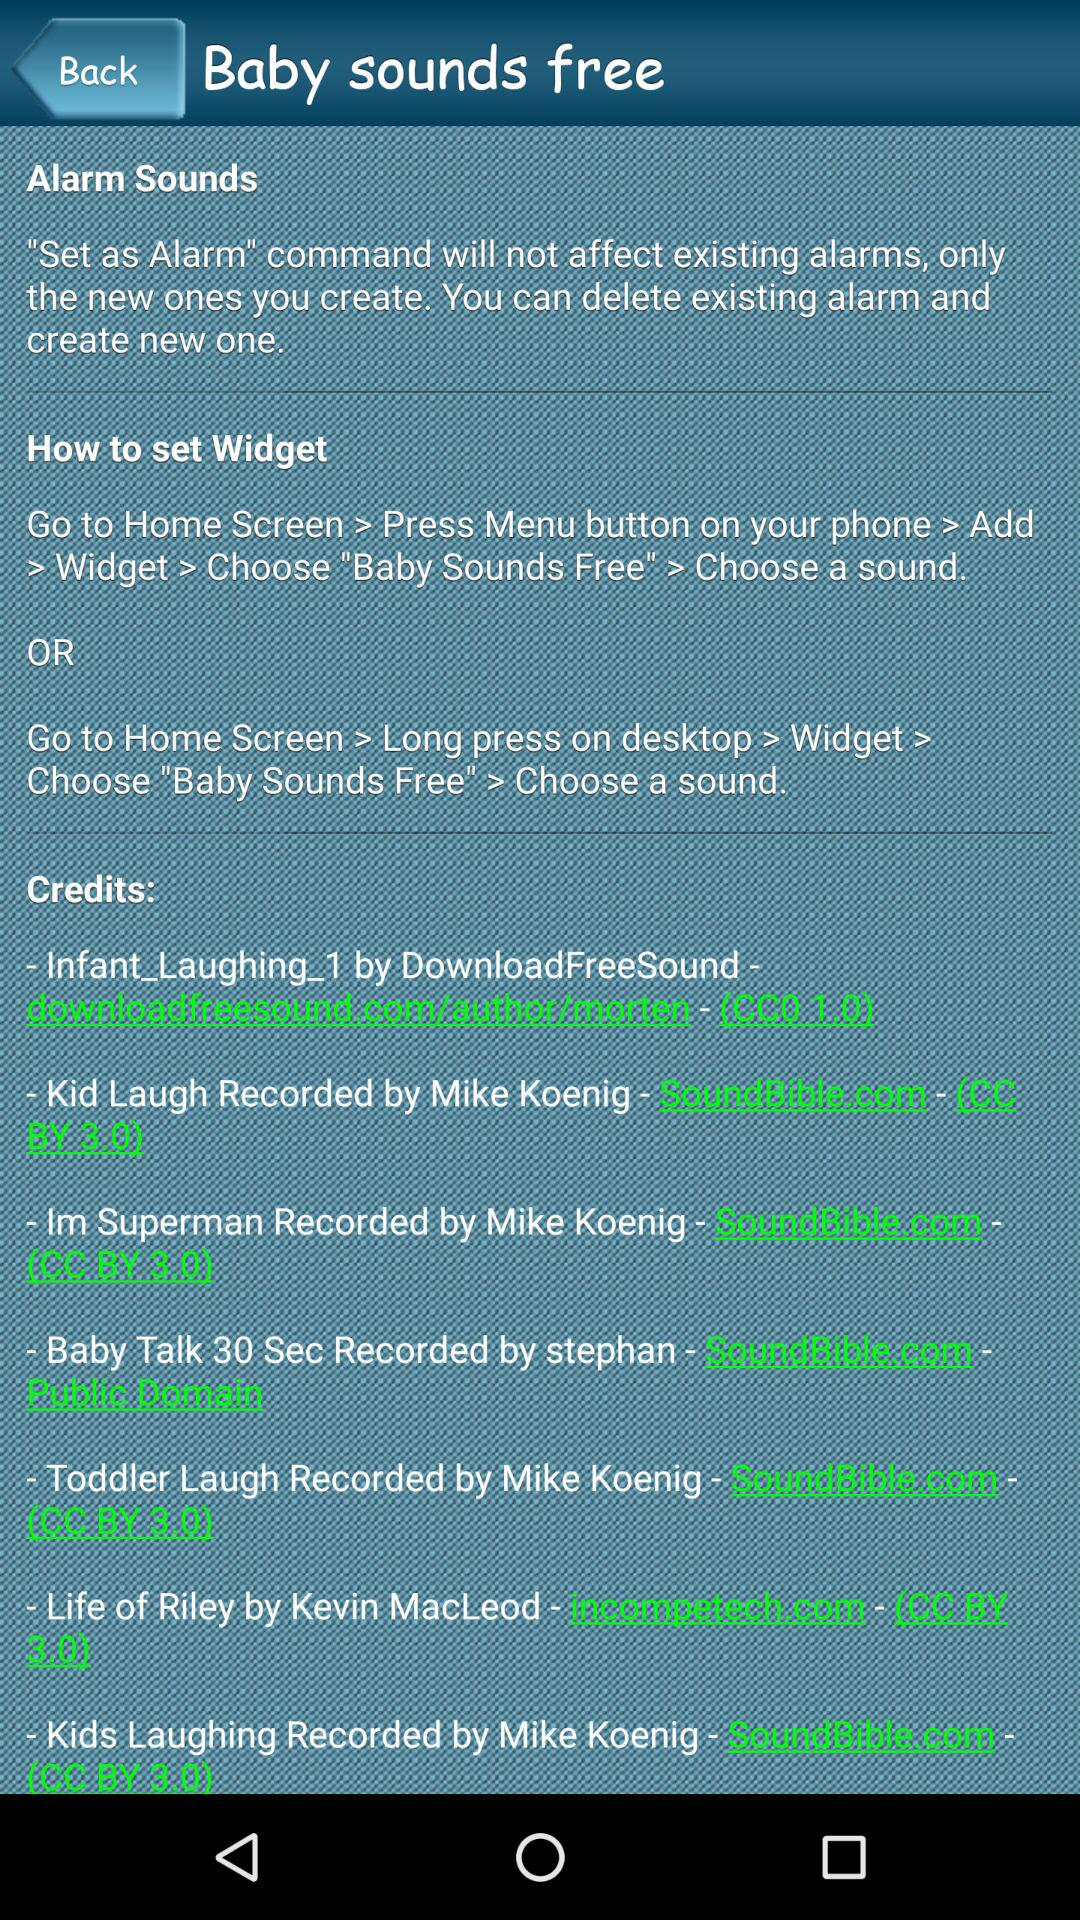What are the instruction given to set alarm?
When the provided information is insufficient, respond with <no answer>. <no answer> 